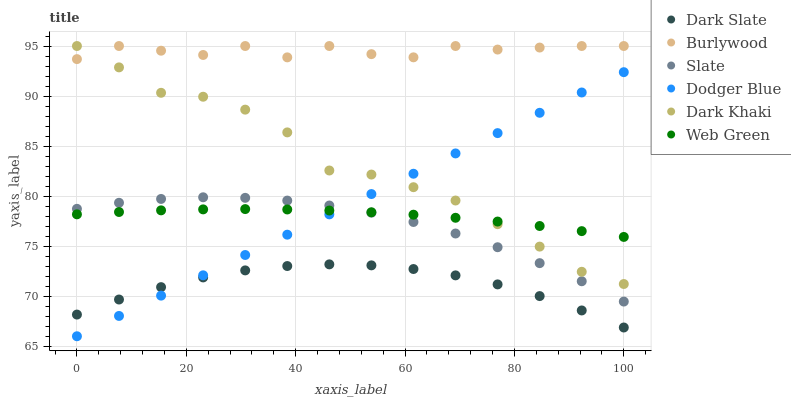Does Dark Slate have the minimum area under the curve?
Answer yes or no. Yes. Does Burlywood have the maximum area under the curve?
Answer yes or no. Yes. Does Slate have the minimum area under the curve?
Answer yes or no. No. Does Slate have the maximum area under the curve?
Answer yes or no. No. Is Dodger Blue the smoothest?
Answer yes or no. Yes. Is Burlywood the roughest?
Answer yes or no. Yes. Is Slate the smoothest?
Answer yes or no. No. Is Slate the roughest?
Answer yes or no. No. Does Dodger Blue have the lowest value?
Answer yes or no. Yes. Does Slate have the lowest value?
Answer yes or no. No. Does Dark Khaki have the highest value?
Answer yes or no. Yes. Does Slate have the highest value?
Answer yes or no. No. Is Dark Slate less than Burlywood?
Answer yes or no. Yes. Is Burlywood greater than Web Green?
Answer yes or no. Yes. Does Dodger Blue intersect Dark Slate?
Answer yes or no. Yes. Is Dodger Blue less than Dark Slate?
Answer yes or no. No. Is Dodger Blue greater than Dark Slate?
Answer yes or no. No. Does Dark Slate intersect Burlywood?
Answer yes or no. No. 